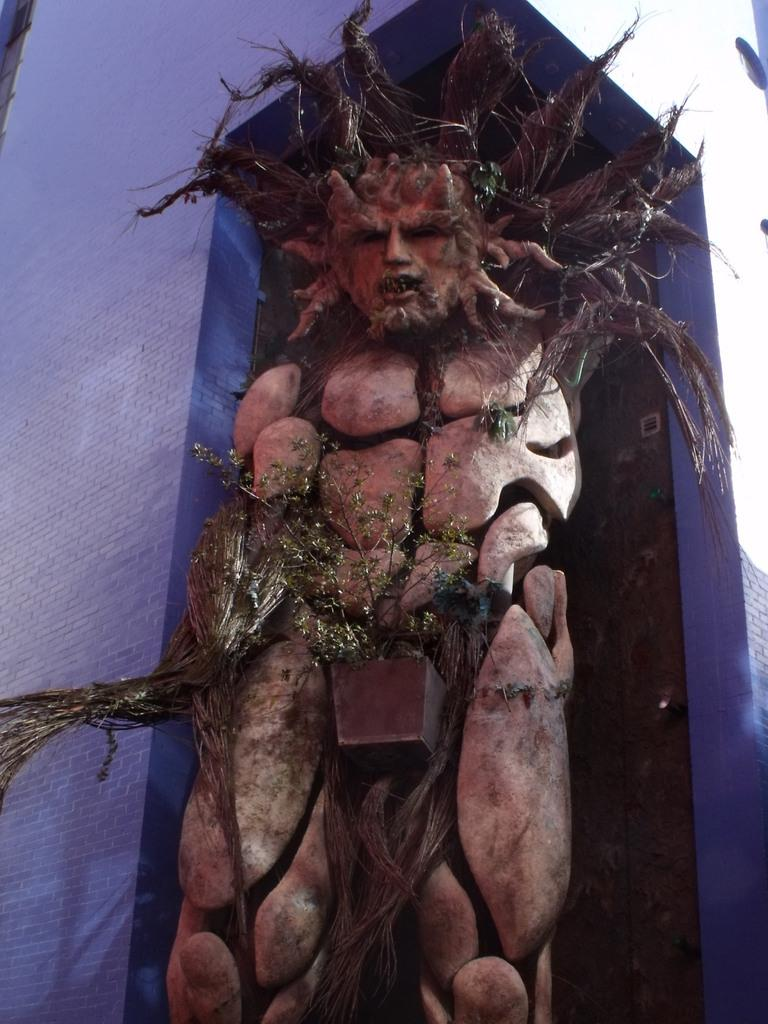What is the main subject in the image? There is a statue in the image. What other object can be seen in the image? There is a plant in the image. What color are the walls in the image? The walls in the image are purple. How many pots are used to hold the plant in the image? There is no pot mentioned or visible in the image; the plant is not shown in a pot. 